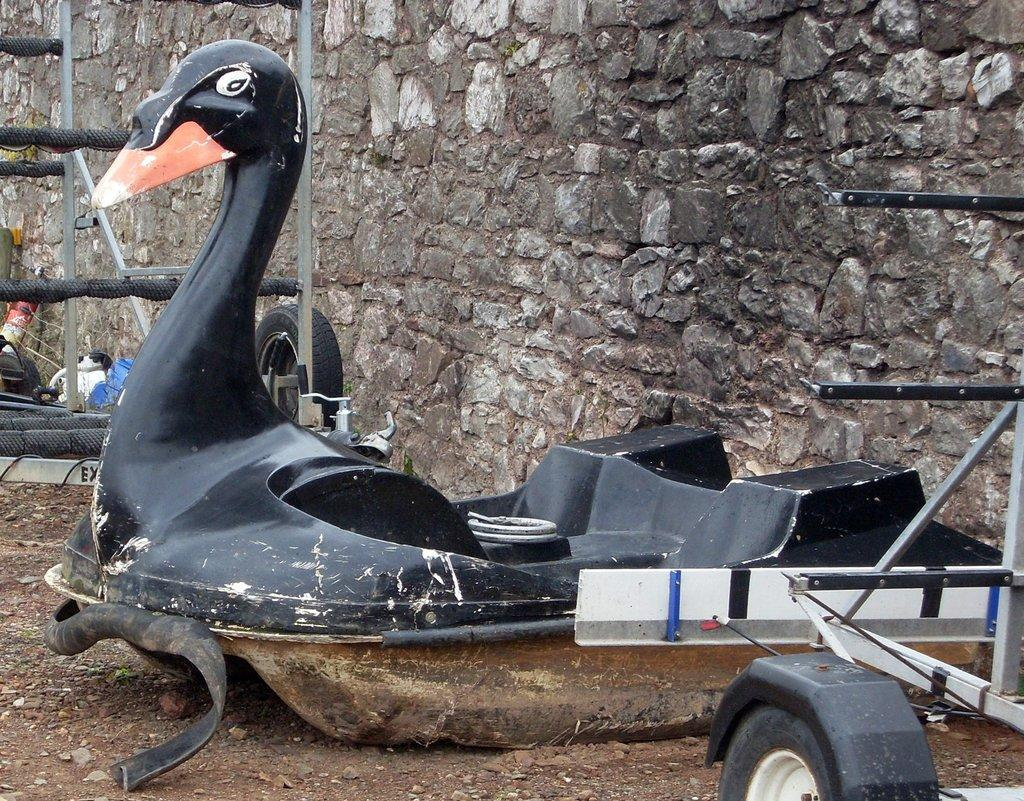What type of vehicle is depicted in the image? There is a duck-shaped vehicle in the image. What is located behind the vehicle? There is a wall behind the vehicle. What material is used to make the metal object in the image? The metal object in the image is made of metal. Can you describe the metal rods in the image? There are metal rods in the image, and they have text or type attached to them. How many hands are visible holding a bucket in the image? There are no hands or buckets present in the image. What type of mask is the duck wearing in the image? The image does not depict a duck wearing a mask; it is a duck-shaped vehicle. 